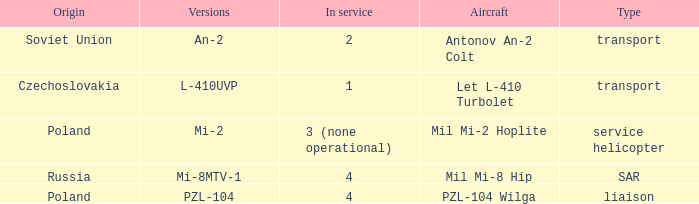Tell me the service for versions l-410uvp 1.0. 